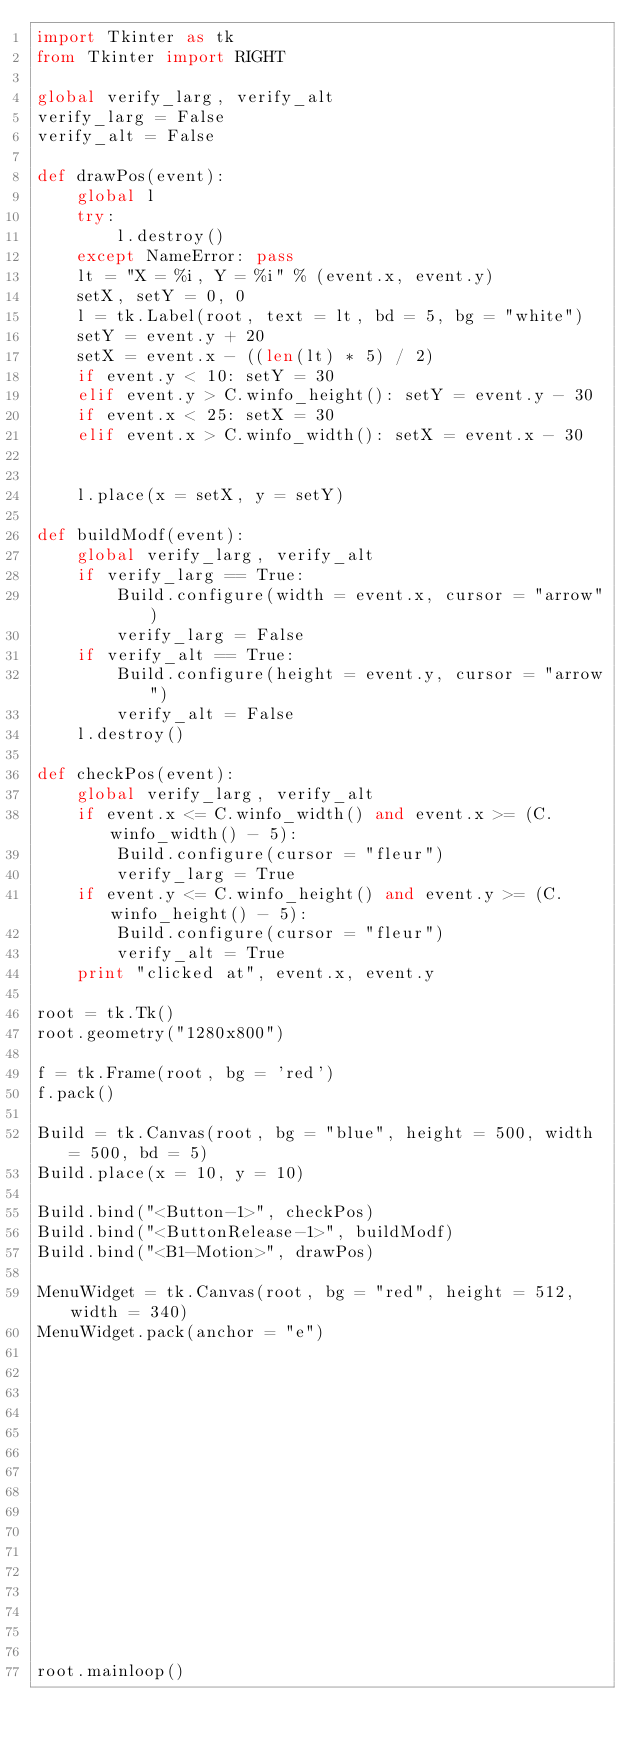Convert code to text. <code><loc_0><loc_0><loc_500><loc_500><_Python_>import Tkinter as tk
from Tkinter import RIGHT

global verify_larg, verify_alt
verify_larg = False
verify_alt = False

def drawPos(event):
    global l
    try:
        l.destroy()
    except NameError: pass
    lt = "X = %i, Y = %i" % (event.x, event.y)
    setX, setY = 0, 0
    l = tk.Label(root, text = lt, bd = 5, bg = "white")
    setY = event.y + 20
    setX = event.x - ((len(lt) * 5) / 2)
    if event.y < 10: setY = 30
    elif event.y > C.winfo_height(): setY = event.y - 30
    if event.x < 25: setX = 30
    elif event.x > C.winfo_width(): setX = event.x - 30


    l.place(x = setX, y = setY)

def buildModf(event):
    global verify_larg, verify_alt
    if verify_larg == True:
        Build.configure(width = event.x, cursor = "arrow")
        verify_larg = False
    if verify_alt == True:
        Build.configure(height = event.y, cursor = "arrow")
        verify_alt = False
    l.destroy()
        
def checkPos(event):
    global verify_larg, verify_alt
    if event.x <= C.winfo_width() and event.x >= (C.winfo_width() - 5):
        Build.configure(cursor = "fleur")
        verify_larg = True
    if event.y <= C.winfo_height() and event.y >= (C.winfo_height() - 5):
        Build.configure(cursor = "fleur")
        verify_alt = True
    print "clicked at", event.x, event.y
    
root = tk.Tk()
root.geometry("1280x800")

f = tk.Frame(root, bg = 'red')
f.pack()

Build = tk.Canvas(root, bg = "blue", height = 500, width = 500, bd = 5)
Build.place(x = 10, y = 10)

Build.bind("<Button-1>", checkPos)
Build.bind("<ButtonRelease-1>", buildModf)
Build.bind("<B1-Motion>", drawPos)

MenuWidget = tk.Canvas(root, bg = "red", height = 512, width = 340)
MenuWidget.pack(anchor = "e")
















root.mainloop()</code> 